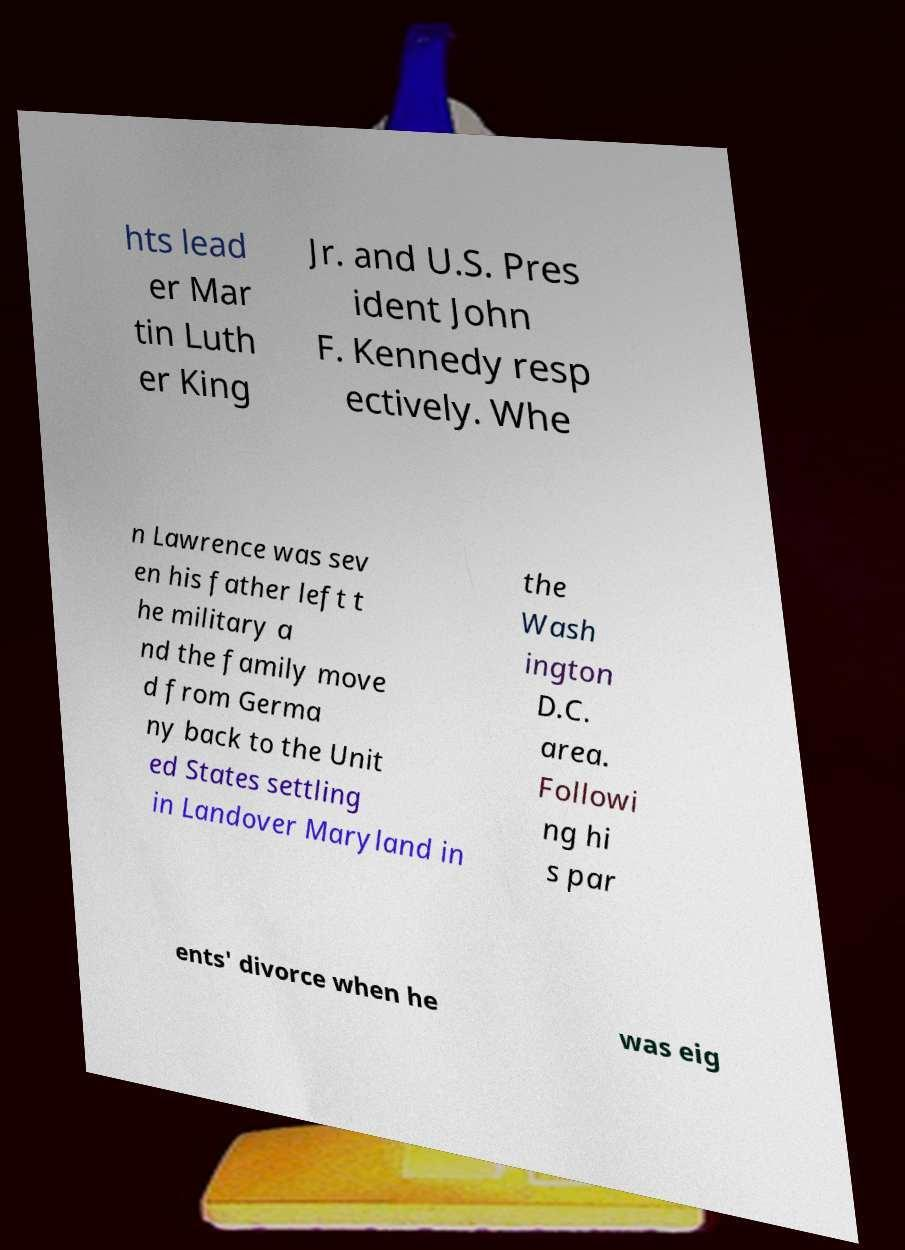What messages or text are displayed in this image? I need them in a readable, typed format. hts lead er Mar tin Luth er King Jr. and U.S. Pres ident John F. Kennedy resp ectively. Whe n Lawrence was sev en his father left t he military a nd the family move d from Germa ny back to the Unit ed States settling in Landover Maryland in the Wash ington D.C. area. Followi ng hi s par ents' divorce when he was eig 